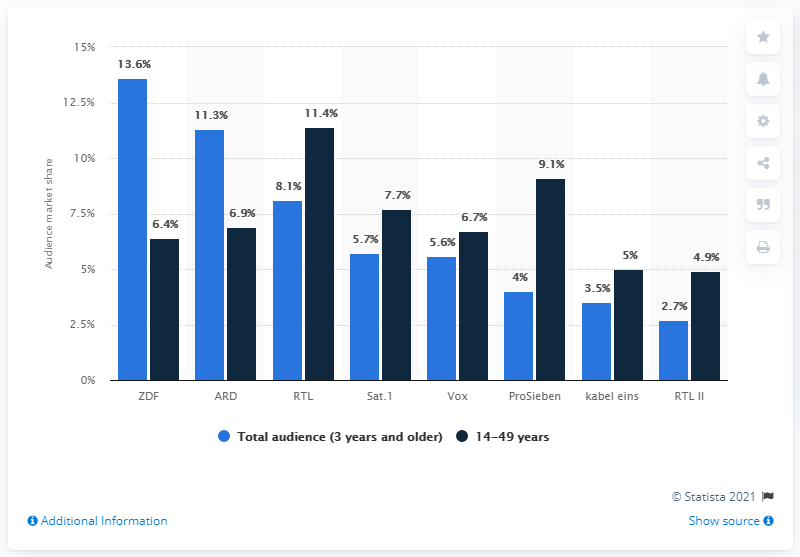Point out several critical features in this image. The market share of ZDF among three-year-olds was 13.6%. According to the data, the market share of ZDF among individuals aged 14 to 49 was 6.4%. 